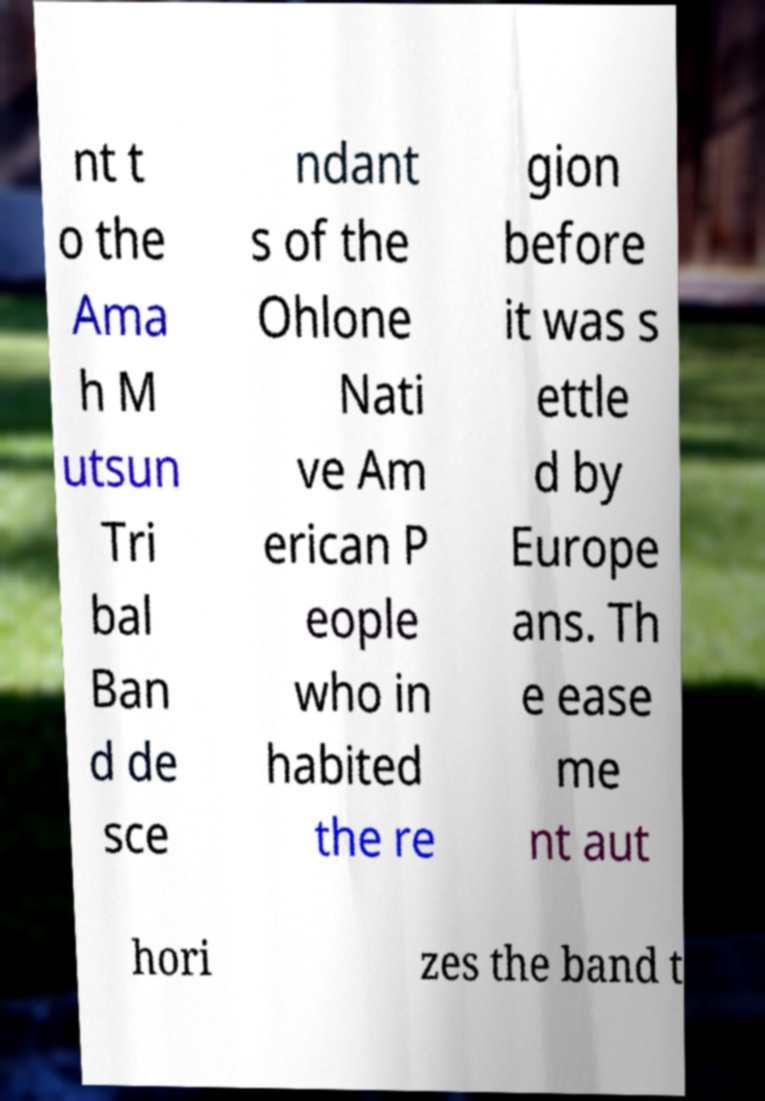Can you read and provide the text displayed in the image?This photo seems to have some interesting text. Can you extract and type it out for me? nt t o the Ama h M utsun Tri bal Ban d de sce ndant s of the Ohlone Nati ve Am erican P eople who in habited the re gion before it was s ettle d by Europe ans. Th e ease me nt aut hori zes the band t 